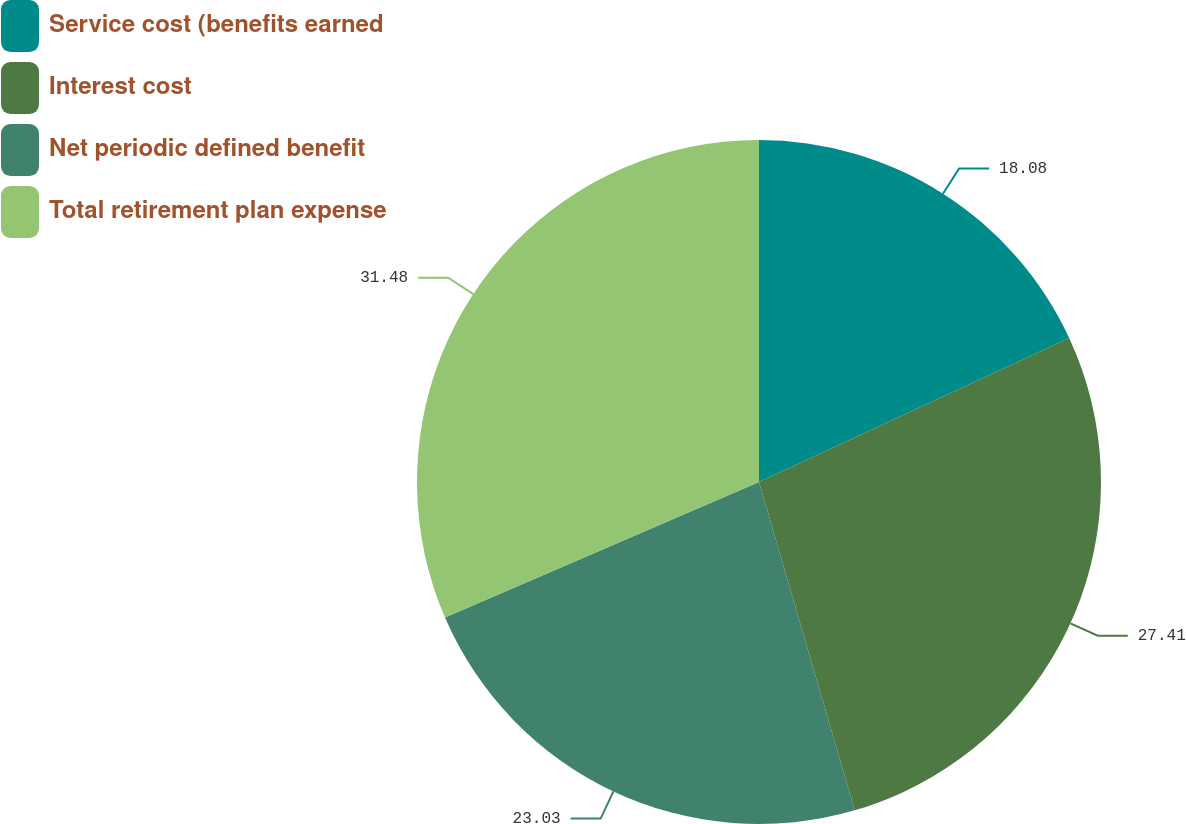<chart> <loc_0><loc_0><loc_500><loc_500><pie_chart><fcel>Service cost (benefits earned<fcel>Interest cost<fcel>Net periodic defined benefit<fcel>Total retirement plan expense<nl><fcel>18.08%<fcel>27.41%<fcel>23.03%<fcel>31.49%<nl></chart> 